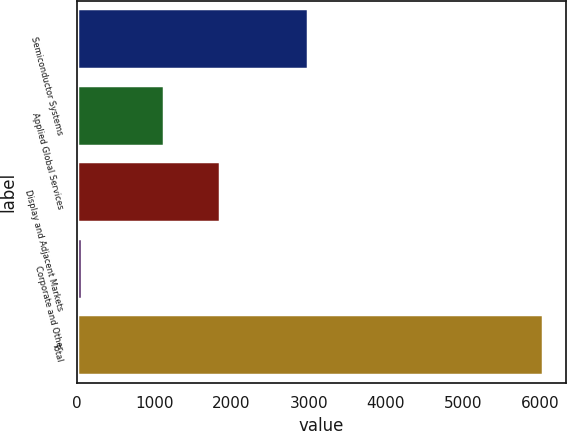<chart> <loc_0><loc_0><loc_500><loc_500><bar_chart><fcel>Semiconductor Systems<fcel>Applied Global Services<fcel>Display and Adjacent Markets<fcel>Corporate and Other<fcel>Total<nl><fcel>2991<fcel>1130<fcel>1847<fcel>63<fcel>6031<nl></chart> 